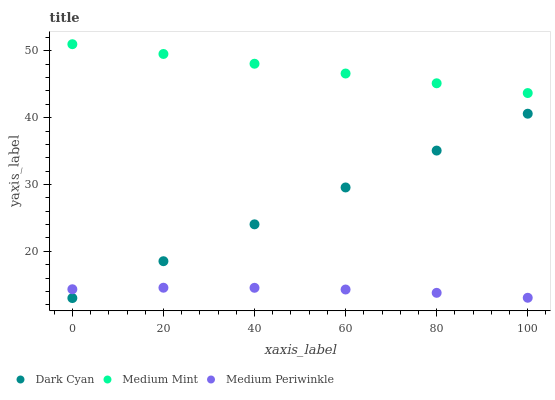Does Medium Periwinkle have the minimum area under the curve?
Answer yes or no. Yes. Does Medium Mint have the maximum area under the curve?
Answer yes or no. Yes. Does Medium Mint have the minimum area under the curve?
Answer yes or no. No. Does Medium Periwinkle have the maximum area under the curve?
Answer yes or no. No. Is Dark Cyan the smoothest?
Answer yes or no. Yes. Is Medium Periwinkle the roughest?
Answer yes or no. Yes. Is Medium Mint the smoothest?
Answer yes or no. No. Is Medium Mint the roughest?
Answer yes or no. No. Does Dark Cyan have the lowest value?
Answer yes or no. Yes. Does Medium Periwinkle have the lowest value?
Answer yes or no. No. Does Medium Mint have the highest value?
Answer yes or no. Yes. Does Medium Periwinkle have the highest value?
Answer yes or no. No. Is Medium Periwinkle less than Medium Mint?
Answer yes or no. Yes. Is Medium Mint greater than Medium Periwinkle?
Answer yes or no. Yes. Does Dark Cyan intersect Medium Periwinkle?
Answer yes or no. Yes. Is Dark Cyan less than Medium Periwinkle?
Answer yes or no. No. Is Dark Cyan greater than Medium Periwinkle?
Answer yes or no. No. Does Medium Periwinkle intersect Medium Mint?
Answer yes or no. No. 